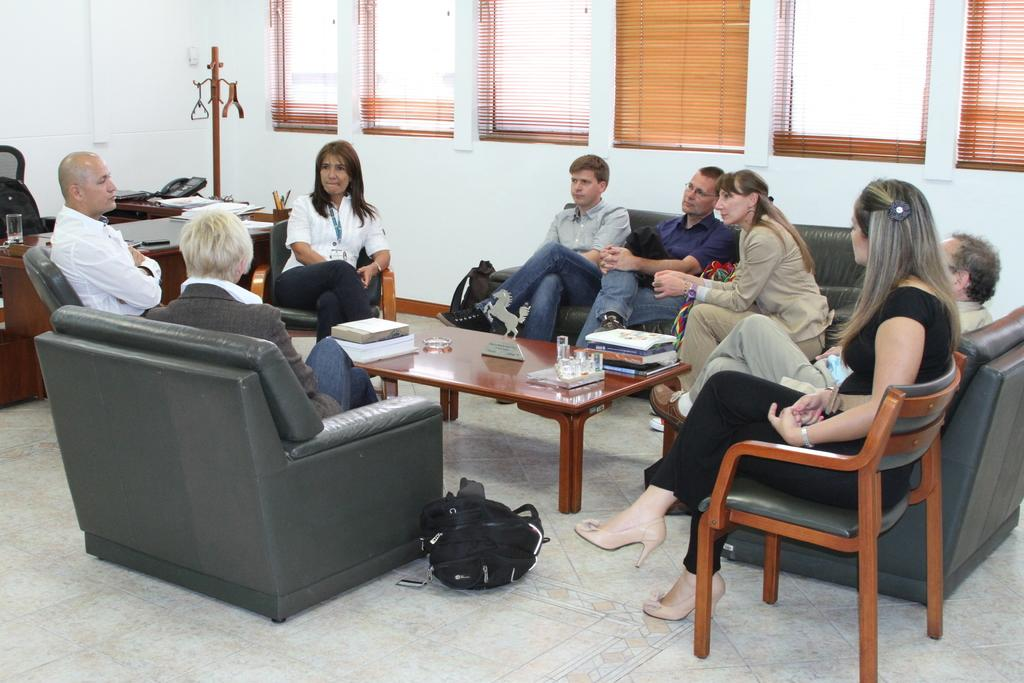What is the main subject of the image? The main subject of the image is a group of people. What are the people doing in the image? The people are sitting on sofa chairs. Are there any other types of seating in the image? Yes, there are chairs behind the sofa chairs. What can be seen in the background of the image? There is a window in the background. What type of current is flowing through the chess pieces in the image? There are no chess pieces or current present in the image. 